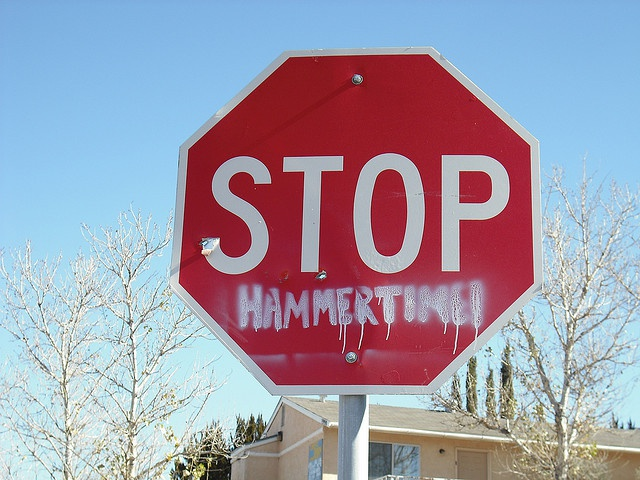Describe the objects in this image and their specific colors. I can see a stop sign in lightblue, brown, darkgray, and lightgray tones in this image. 